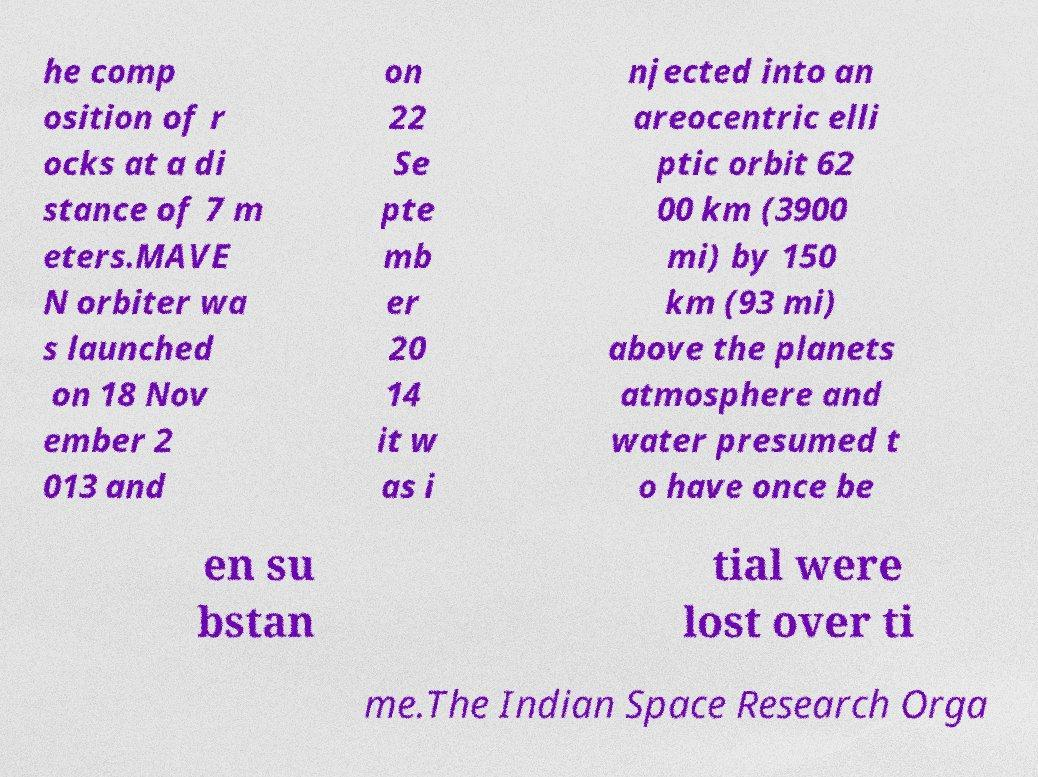Can you accurately transcribe the text from the provided image for me? he comp osition of r ocks at a di stance of 7 m eters.MAVE N orbiter wa s launched on 18 Nov ember 2 013 and on 22 Se pte mb er 20 14 it w as i njected into an areocentric elli ptic orbit 62 00 km (3900 mi) by 150 km (93 mi) above the planets atmosphere and water presumed t o have once be en su bstan tial were lost over ti me.The Indian Space Research Orga 